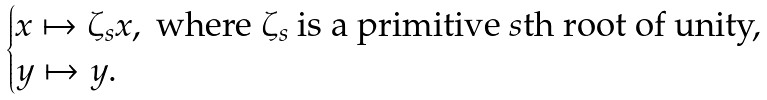Convert formula to latex. <formula><loc_0><loc_0><loc_500><loc_500>\begin{cases} x \mapsto \zeta _ { s } x , \text { where } \zeta _ { s } \text { is a primitive $s$th root of unity,} \\ y \mapsto y . \end{cases}</formula> 